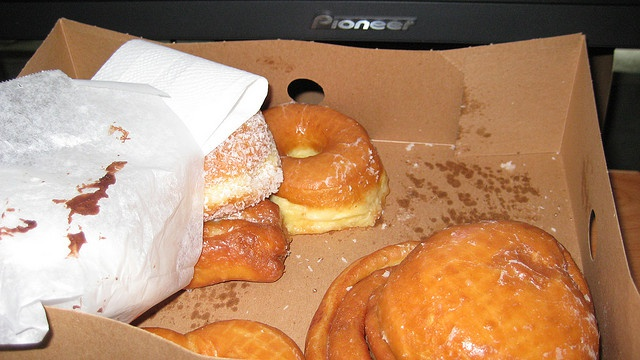Describe the objects in this image and their specific colors. I can see donut in black, orange, and red tones, donut in black, red, and orange tones, donut in black, red, and salmon tones, donut in black, orange, and red tones, and donut in black, red, salmon, and brown tones in this image. 